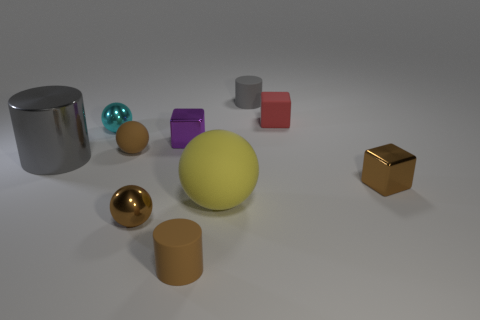What number of red cubes are behind the gray object on the right side of the yellow matte object?
Offer a very short reply. 0. How many gray objects are small shiny objects or small matte spheres?
Your answer should be compact. 0. There is a gray thing that is on the right side of the brown metal object that is on the left side of the small metal block behind the metal cylinder; what shape is it?
Offer a very short reply. Cylinder. The shiny object that is the same size as the yellow ball is what color?
Offer a terse response. Gray. What number of purple metallic things are the same shape as the tiny red object?
Provide a short and direct response. 1. Do the brown cylinder and the gray thing that is left of the brown rubber cylinder have the same size?
Make the answer very short. No. There is a small brown metal object on the left side of the tiny matte cylinder in front of the purple thing; what is its shape?
Provide a succinct answer. Sphere. Are there fewer big gray shiny cylinders behind the small gray cylinder than small brown metallic spheres?
Offer a terse response. Yes. There is a tiny matte thing that is the same color as the big metallic cylinder; what is its shape?
Your answer should be compact. Cylinder. How many gray matte things are the same size as the cyan sphere?
Your answer should be compact. 1. 